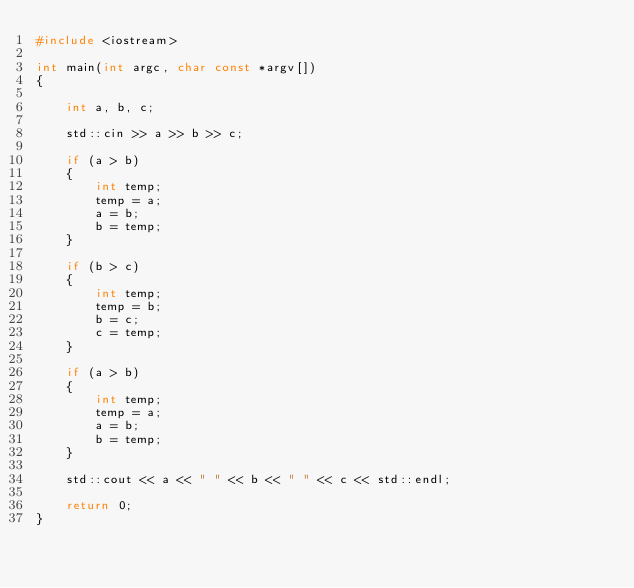Convert code to text. <code><loc_0><loc_0><loc_500><loc_500><_C++_>#include <iostream>

int main(int argc, char const *argv[])
{

    int a, b, c;

    std::cin >> a >> b >> c;

    if (a > b)
    {
        int temp;
        temp = a;
        a = b;
        b = temp;
    }

    if (b > c)
    {
        int temp;
        temp = b;
        b = c;
        c = temp;
    }

    if (a > b)
    {
        int temp;
        temp = a;
        a = b;
        b = temp;
    }

    std::cout << a << " " << b << " " << c << std::endl;

    return 0;
}

</code> 